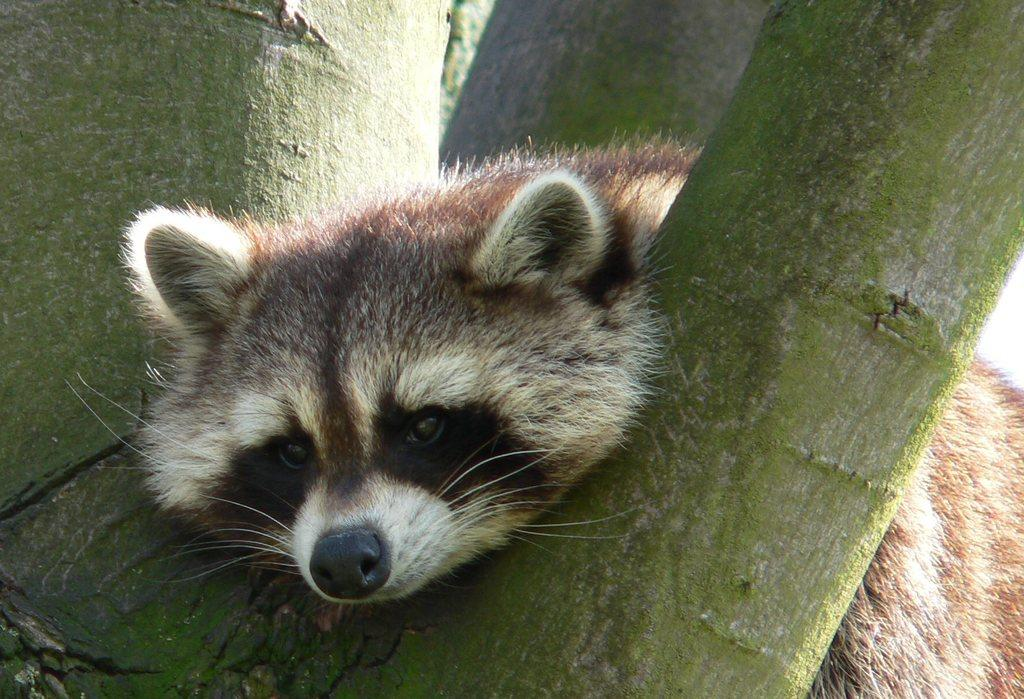What type of animal is in the image? There is a raccoon in the image. What is the raccoon doing in the image? The raccoon is lying on a tree branch. What type of drain can be seen in the image? There is no drain present in the image. What type of bushes can be seen in the image? There is no mention of bushes in the provided facts, so we cannot determine if they are present in the image. 